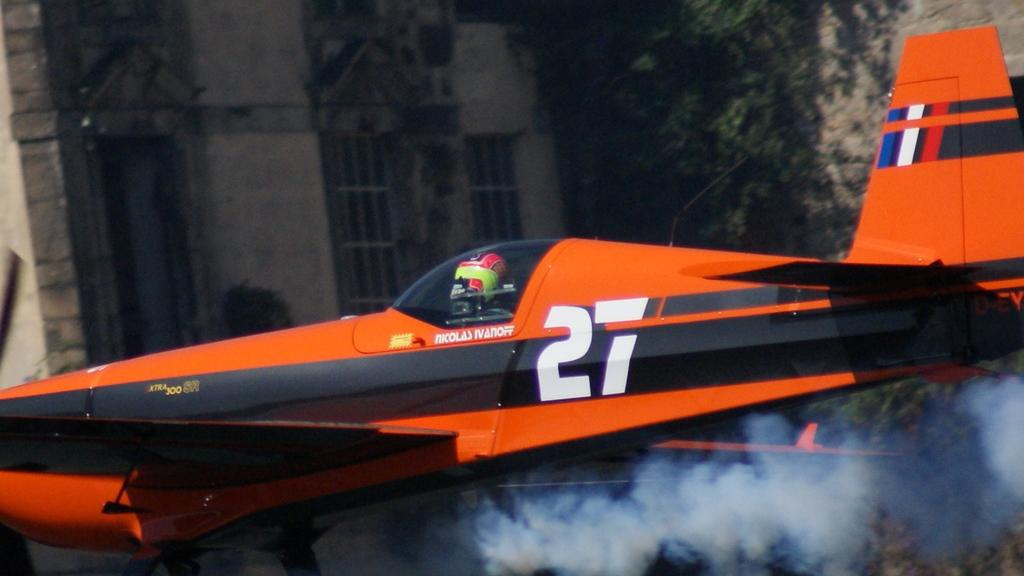<image>
Render a clear and concise summary of the photo. Nicolas Ivanoff flies his red number 27 plane. 